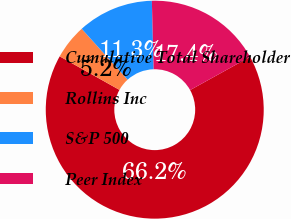<chart> <loc_0><loc_0><loc_500><loc_500><pie_chart><fcel>Cumulative Total Shareholder<fcel>Rollins Inc<fcel>S&P 500<fcel>Peer Index<nl><fcel>66.19%<fcel>5.17%<fcel>11.27%<fcel>17.37%<nl></chart> 